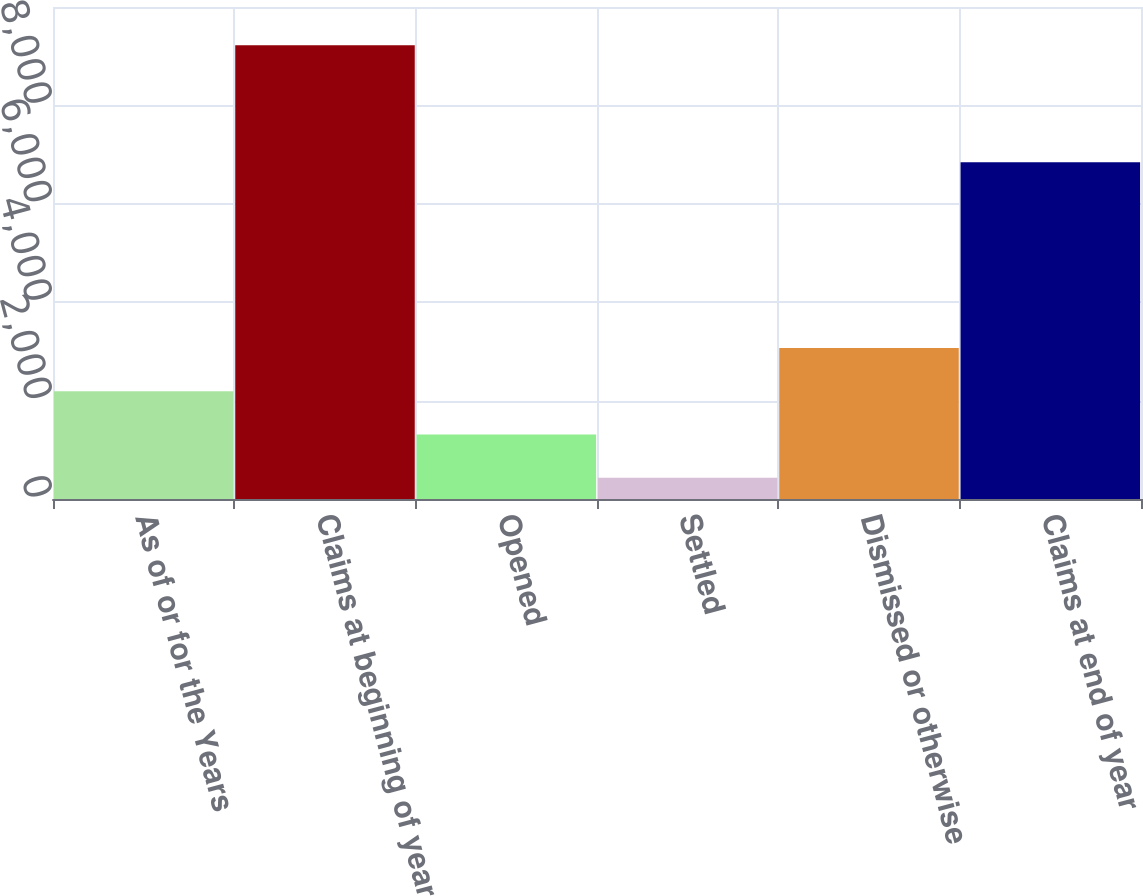Convert chart. <chart><loc_0><loc_0><loc_500><loc_500><bar_chart><fcel>As of or for the Years<fcel>Claims at beginning of year<fcel>Opened<fcel>Settled<fcel>Dismissed or otherwise<fcel>Claims at end of year<nl><fcel>2191.4<fcel>9225<fcel>1312.2<fcel>433<fcel>3070.6<fcel>6844<nl></chart> 